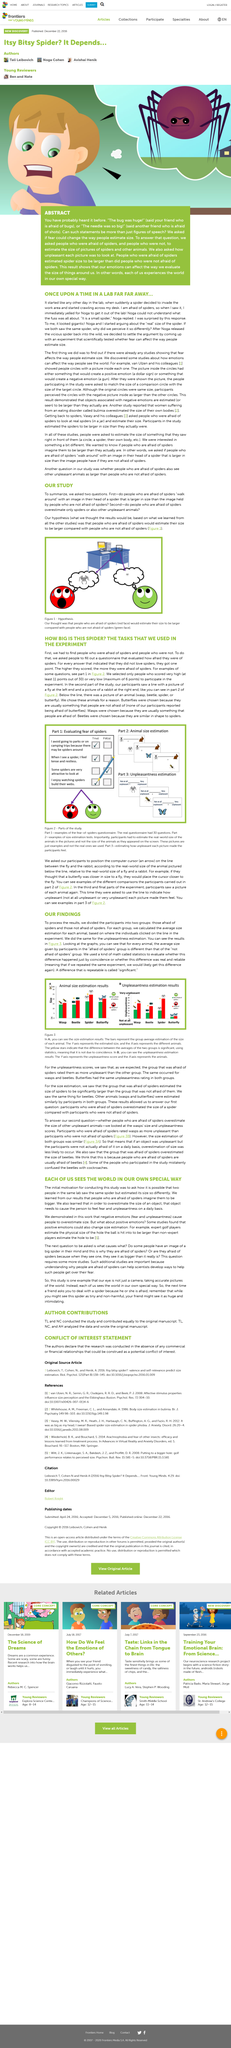Mention a couple of crucial points in this snapshot. Golf experts are believed to have a larger perception of golf holes compared to non-experts, as suggested by their estimates. The size of a spider perceived by those who are afraid of spiders is larger than that perceived by those who are not afraid of spiders. Yes, our emotions can affect how we perceive the size of things around us. A repeatable difference that is significant is referred to as significance. They studied the phenomenon using the fear of spiders as their primary tool. 